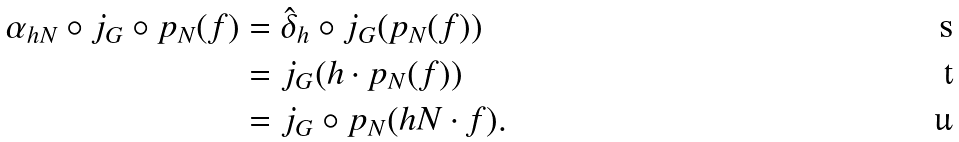Convert formula to latex. <formula><loc_0><loc_0><loc_500><loc_500>\alpha _ { h N } \circ j _ { G } \circ p _ { N } ( f ) & = \hat { \delta } _ { h } \circ j _ { G } ( p _ { N } ( f ) ) \\ & = j _ { G } ( h \cdot p _ { N } ( f ) ) \\ & = j _ { G } \circ p _ { N } ( h N \cdot f ) .</formula> 